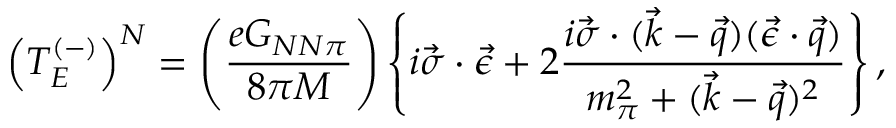<formula> <loc_0><loc_0><loc_500><loc_500>\left ( T _ { E } ^ { ( - ) } \right ) ^ { N } = \left ( { \frac { e G _ { N N \pi } } { 8 \pi M } } \right ) \left \{ i \vec { \sigma } \cdot \vec { \epsilon } + 2 { \frac { i \vec { \sigma } \cdot ( \vec { k } - \vec { q } ) ( \vec { \epsilon } \cdot \vec { q } ) } { m _ { \pi } ^ { 2 } + ( \vec { k } - \vec { q } ) ^ { 2 } } } \right \} ,</formula> 